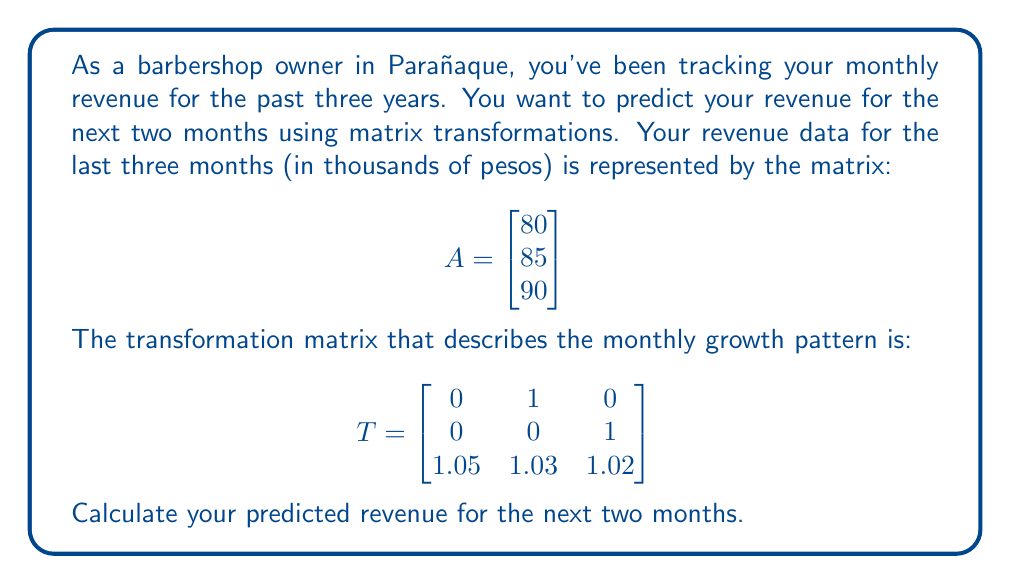Give your solution to this math problem. To solve this problem, we need to apply the transformation matrix T to the revenue matrix A twice, as we want to predict two months into the future.

Step 1: Calculate the revenue for the next month (A'):
$$A' = T \cdot A = \begin{bmatrix} 0 & 1 & 0 \\ 0 & 0 & 1 \\ 1.05 & 1.03 & 1.02 \end{bmatrix} \cdot \begin{bmatrix} 80 \\ 85 \\ 90 \end{bmatrix}$$

$$A' = \begin{bmatrix} 85 \\ 90 \\ 84 + 87.55 + 91.8 \end{bmatrix} = \begin{bmatrix} 85 \\ 90 \\ 263.35 \end{bmatrix}$$

Step 2: Calculate the revenue for the second month (A''):
$$A'' = T \cdot A' = \begin{bmatrix} 0 & 1 & 0 \\ 0 & 0 & 1 \\ 1.05 & 1.03 & 1.02 \end{bmatrix} \cdot \begin{bmatrix} 85 \\ 90 \\ 263.35 \end{bmatrix}$$

$$A'' = \begin{bmatrix} 90 \\ 263.35 \\ 89.25 + 92.7 + 268.617 \end{bmatrix} = \begin{bmatrix} 90 \\ 263.35 \\ 450.567 \end{bmatrix}$$

The predicted revenues for the next two months are the last elements of A' and A'', respectively:
Month 1: 263.35 thousand pesos
Month 2: 450.567 thousand pesos
Answer: 263.35, 450.567 (in thousands of pesos) 